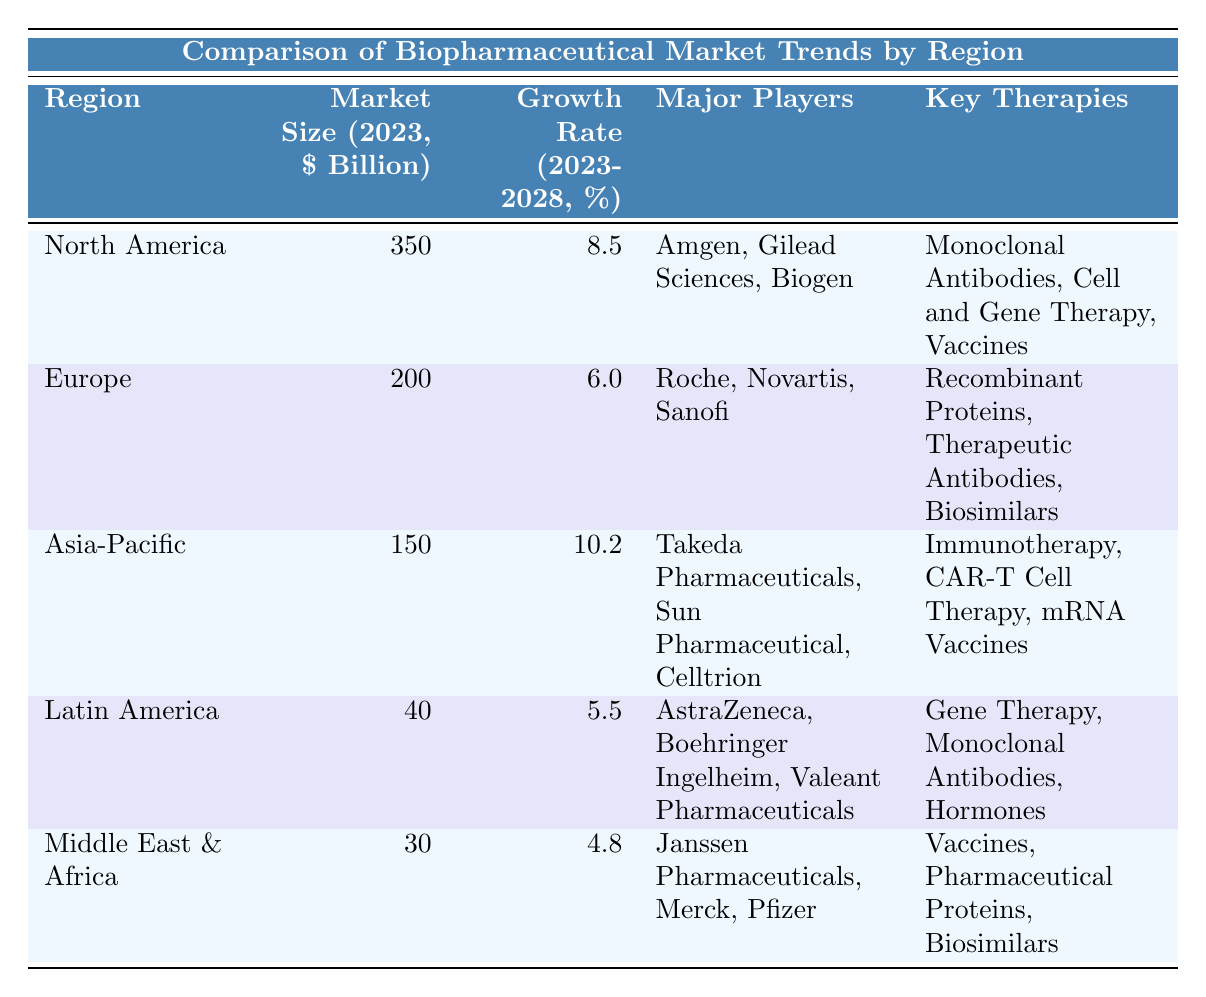What is the market size of North America in 2023? The table states that the market size for North America in 2023 is listed under the "Market Size (2023, $ Billion)" column as 350.
Answer: 350 Which region has the highest growth rate from 2023 to 2028? The growth rates for each region are found in the "Growth Rate (2023-2028, %)" column. North America has 8.5%, Asia-Pacific has 10.2%, Europe has 6.0%, Latin America has 5.5%, and Middle East & Africa has 4.8%. By comparing these values, Asia-Pacific has the highest growth rate at 10.2%.
Answer: Asia-Pacific What are the major players in the Europe region? The table lists "Major Players" for Europe, which includes Roche, Novartis, and Sanofi.
Answer: Roche, Novartis, Sanofi Is it true that the Middle East & Africa region has a market size larger than Latin America? The market sizes for Middle East & Africa and Latin America are 30 billion and 40 billion, respectively. Since 30 is less than 40, it is false that the Middle East & Africa has a larger market size than Latin America.
Answer: False What is the combined market size of North America and Asia-Pacific in 2023? The market sizes for North America (350 billion) and Asia-Pacific (150 billion) are summed: 350 + 150 = 500 billion.
Answer: 500 Which region has the lowest growth rate, and what is that rate? The growth rates for each region are compared: North America (8.5%), Europe (6.0%), Asia-Pacific (10.2%), Latin America (5.5%), and Middle East & Africa (4.8%). Middle East & Africa has the lowest growth rate at 4.8%.
Answer: Middle East & Africa, 4.8% Can you name one key therapy for each region? Each region has a specific set of "Key Therapies" listed: North America has Monoclonal Antibodies, Europe has Recombinant Proteins, Asia-Pacific has Immunotherapy, Latin America has Gene Therapy, and Middle East & Africa has Vaccines.
Answer: Monoclonal Antibodies, Recombinant Proteins, Immunotherapy, Gene Therapy, Vaccines What is the average market size across all the regions for 2023? The market sizes for all regions are added: 350 + 200 + 150 + 40 + 30 = 770 billion. There are 5 regions, so the average is 770 / 5 = 154 billion.
Answer: 154 If you ranked the regions by market size, what would the top three regions be? The market sizes are ranked as follows: North America (350 billion), Europe (200 billion), Asia-Pacific (150 billion). Therefore, the top three regions are North America, Europe, and Asia-Pacific.
Answer: North America, Europe, Asia-Pacific Which major player is involved in the Latin America region? The "Major Players" for Latin America as listed in the table includes AstraZeneca, Boehringer Ingelheim, and Valeant Pharmaceuticals.
Answer: AstraZeneca, Boehringer Ingelheim, Valeant Pharmaceuticals 